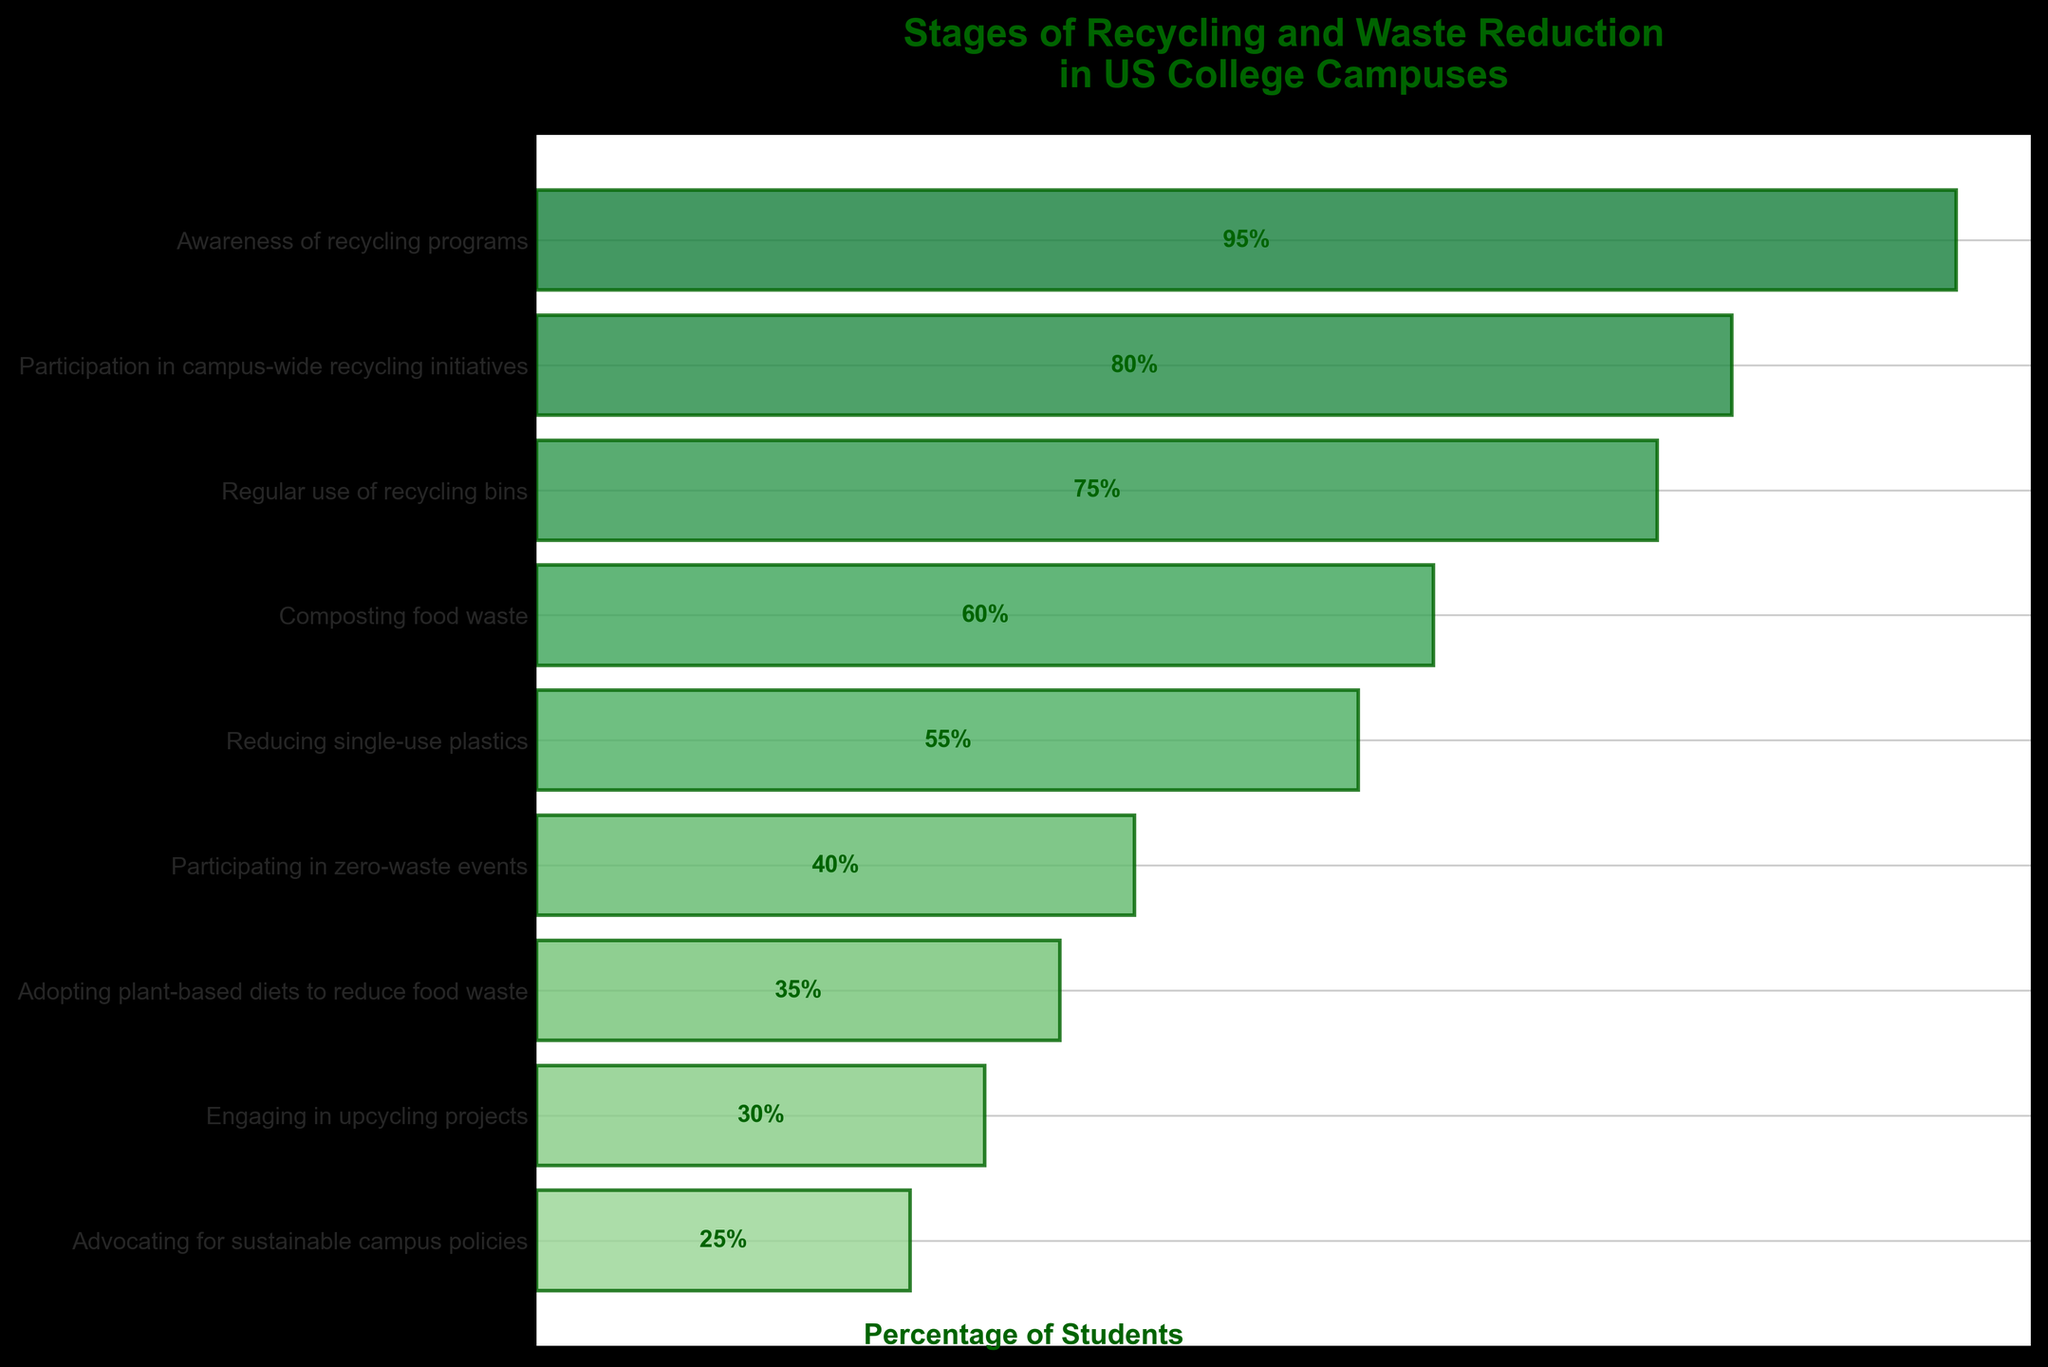What is the title of the funnel chart? The title of the funnel chart is usually placed at the top center of the figure and provides an overview of what the chart represents. In this case, it clearly states the focus of the chart.
Answer: Stages of Recycling and Waste Reduction in US College Campuses What is the percentage of students regularly using recycling bins? Locate the stage labeled "Regular use of recycling bins" and refer to the percentage displayed within that bar.
Answer: 75% Which stage has the lowest percentage of student participation? Look for the bar with the smallest percentage value. In this case, it is the bar furthest to the left.
Answer: Advocating for sustainable campus policies What is the difference in percentage between students participating in campus-wide recycling initiatives and those engaging in upcycling projects? Find the percentage for "Participation in campus-wide recycling initiatives" (80%) and "Engaging in upcycling projects" (30%), then calculate the difference, which is 80% - 30% = 50%.
Answer: 50% How does the percentage of students adopting plant-based diets to reduce food waste compare with those participating in zero-waste events? Find the percentage for "Adopting plant-based diets to reduce food waste" (35%) and "Participating in zero-waste events" (40%), then note that 35% is less than 40%.
Answer: Less What percentage of students are involved in composting food waste? Locate the stage labeled "Composting food waste" and refer to the percentage displayed within that bar.
Answer: 60% What is the average percentage for the stages related to reducing single-use plastics and participating in zero-waste events? Find the percentage for "Reducing single-use plastics" (55%) and "Participating in zero-waste events" (40%), then calculate the average, which is (55% + 40%) / 2 = 47.5%.
Answer: 47.5% What is the median percentage among all the stages listed in the funnel chart? List all percentages (95%, 80%, 75%, 60%, 55%, 40%, 35%, 30%, 25%) in numerical order, then find the middle value for the median, which is 55%.
Answer: 55% Which stage shows a drop-off of more than 20% from the previous stage? Compare each stage's percentage with the one preceding it and identify if the drop is more than 20%. The stage "Composting food waste" (60%) follows "Regular use of recycling bins" (75%), showing a drop of 15%, while "Reducing single-use plastics" (55%) follows "Composting food waste" (60%), showing a drop of 5%, and so on. The critical drop is found between "Participation in campus-wide recycling initiatives" (80%) and "Regular use of recycling bins" (75%), which is 5%. Continue this evaluation and find "Participating in zero-waste events" (40%) follows "Reducing single-use plastics" (55%), showing a drop of 15%, and "Engaging in upcycling projects" (30%) follows "Participating in zero-waste events" (40%), showing a drop of 10%. Finally, "Adopting plant-based diets to reduce food waste" (35%) follows "Engaging in upcycling projects" (30%), showing a drop of 5%. So, no stage has a drop-off of more than 20%.
Answer: None 